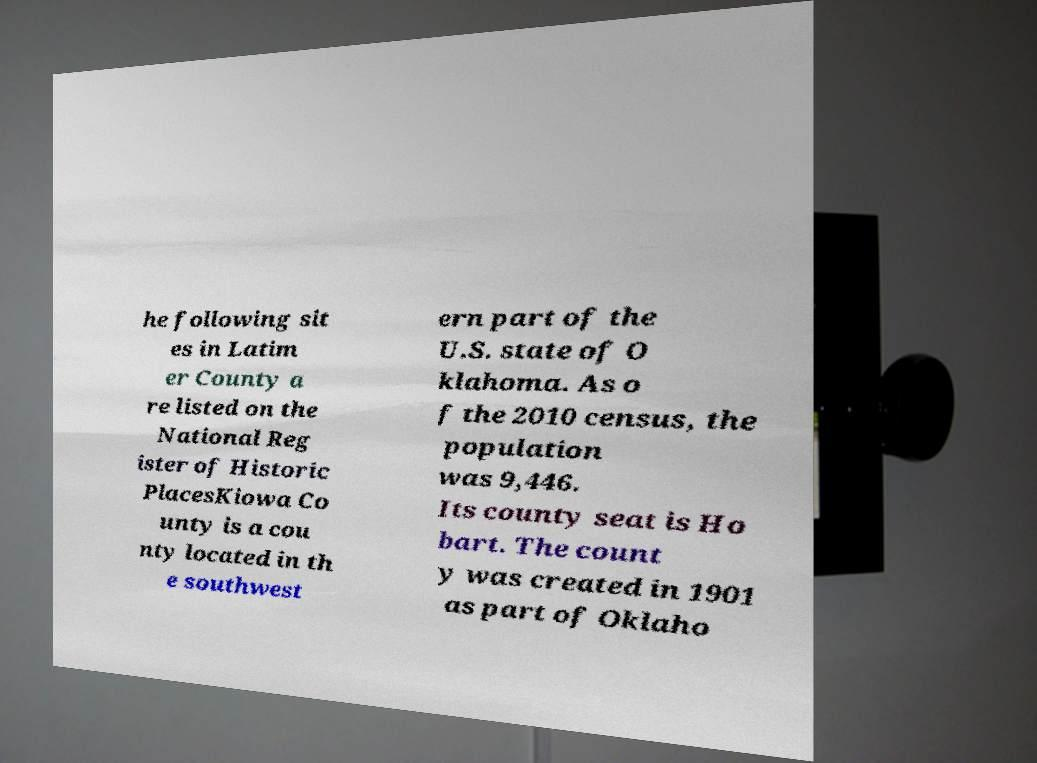Please read and relay the text visible in this image. What does it say? he following sit es in Latim er County a re listed on the National Reg ister of Historic PlacesKiowa Co unty is a cou nty located in th e southwest ern part of the U.S. state of O klahoma. As o f the 2010 census, the population was 9,446. Its county seat is Ho bart. The count y was created in 1901 as part of Oklaho 